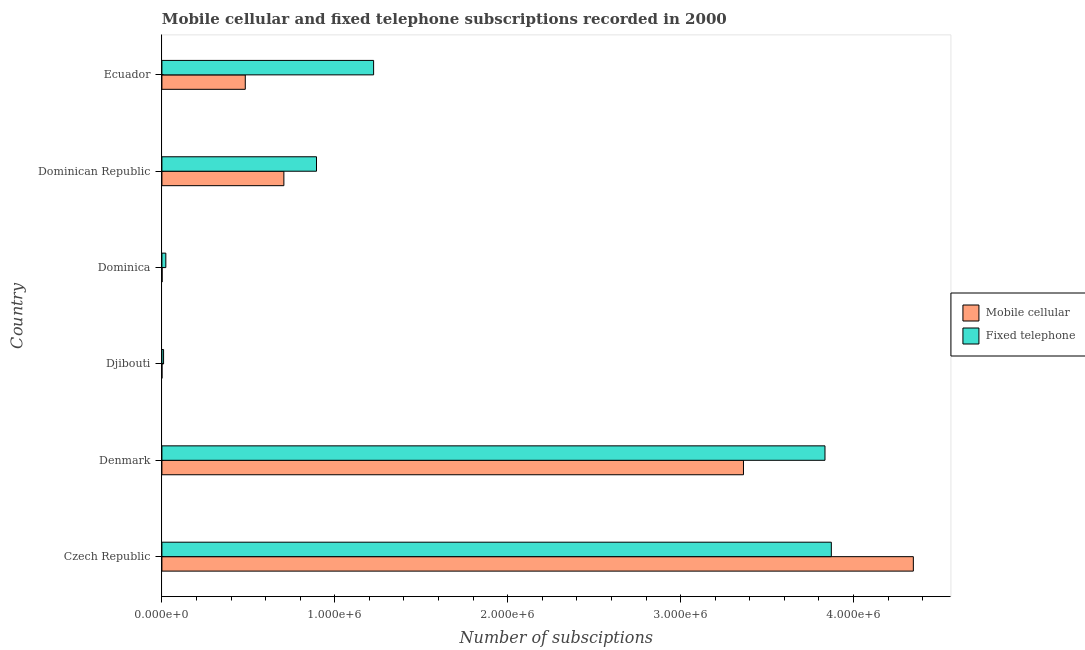Are the number of bars per tick equal to the number of legend labels?
Provide a succinct answer. Yes. Are the number of bars on each tick of the Y-axis equal?
Provide a succinct answer. Yes. What is the label of the 3rd group of bars from the top?
Ensure brevity in your answer.  Dominica. In how many cases, is the number of bars for a given country not equal to the number of legend labels?
Your answer should be very brief. 0. What is the number of fixed telephone subscriptions in Czech Republic?
Provide a succinct answer. 3.87e+06. Across all countries, what is the maximum number of fixed telephone subscriptions?
Ensure brevity in your answer.  3.87e+06. Across all countries, what is the minimum number of fixed telephone subscriptions?
Provide a short and direct response. 9704. In which country was the number of mobile cellular subscriptions maximum?
Offer a very short reply. Czech Republic. In which country was the number of mobile cellular subscriptions minimum?
Your answer should be compact. Djibouti. What is the total number of mobile cellular subscriptions in the graph?
Keep it short and to the point. 8.90e+06. What is the difference between the number of fixed telephone subscriptions in Denmark and that in Dominican Republic?
Offer a very short reply. 2.94e+06. What is the difference between the number of mobile cellular subscriptions in Dominican Republic and the number of fixed telephone subscriptions in Dominica?
Provide a short and direct response. 6.83e+05. What is the average number of fixed telephone subscriptions per country?
Your answer should be very brief. 1.64e+06. What is the difference between the number of fixed telephone subscriptions and number of mobile cellular subscriptions in Djibouti?
Offer a terse response. 9474. In how many countries, is the number of fixed telephone subscriptions greater than 2600000 ?
Ensure brevity in your answer.  2. What is the ratio of the number of mobile cellular subscriptions in Dominica to that in Ecuador?
Your response must be concise. 0. What is the difference between the highest and the second highest number of mobile cellular subscriptions?
Keep it short and to the point. 9.82e+05. What is the difference between the highest and the lowest number of fixed telephone subscriptions?
Provide a succinct answer. 3.86e+06. Is the sum of the number of mobile cellular subscriptions in Czech Republic and Dominica greater than the maximum number of fixed telephone subscriptions across all countries?
Offer a very short reply. Yes. What does the 1st bar from the top in Denmark represents?
Ensure brevity in your answer.  Fixed telephone. What does the 1st bar from the bottom in Denmark represents?
Offer a terse response. Mobile cellular. Are all the bars in the graph horizontal?
Ensure brevity in your answer.  Yes. How many countries are there in the graph?
Keep it short and to the point. 6. Are the values on the major ticks of X-axis written in scientific E-notation?
Offer a terse response. Yes. Does the graph contain any zero values?
Keep it short and to the point. No. Where does the legend appear in the graph?
Ensure brevity in your answer.  Center right. How many legend labels are there?
Provide a succinct answer. 2. What is the title of the graph?
Your response must be concise. Mobile cellular and fixed telephone subscriptions recorded in 2000. Does "Overweight" appear as one of the legend labels in the graph?
Make the answer very short. No. What is the label or title of the X-axis?
Offer a terse response. Number of subsciptions. What is the label or title of the Y-axis?
Give a very brief answer. Country. What is the Number of subsciptions in Mobile cellular in Czech Republic?
Keep it short and to the point. 4.35e+06. What is the Number of subsciptions of Fixed telephone in Czech Republic?
Offer a terse response. 3.87e+06. What is the Number of subsciptions of Mobile cellular in Denmark?
Your answer should be compact. 3.36e+06. What is the Number of subsciptions in Fixed telephone in Denmark?
Keep it short and to the point. 3.84e+06. What is the Number of subsciptions of Mobile cellular in Djibouti?
Provide a short and direct response. 230. What is the Number of subsciptions in Fixed telephone in Djibouti?
Ensure brevity in your answer.  9704. What is the Number of subsciptions of Mobile cellular in Dominica?
Make the answer very short. 1200. What is the Number of subsciptions in Fixed telephone in Dominica?
Give a very brief answer. 2.27e+04. What is the Number of subsciptions in Mobile cellular in Dominican Republic?
Offer a very short reply. 7.05e+05. What is the Number of subsciptions of Fixed telephone in Dominican Republic?
Keep it short and to the point. 8.94e+05. What is the Number of subsciptions in Mobile cellular in Ecuador?
Make the answer very short. 4.82e+05. What is the Number of subsciptions in Fixed telephone in Ecuador?
Provide a short and direct response. 1.22e+06. Across all countries, what is the maximum Number of subsciptions of Mobile cellular?
Provide a succinct answer. 4.35e+06. Across all countries, what is the maximum Number of subsciptions of Fixed telephone?
Offer a very short reply. 3.87e+06. Across all countries, what is the minimum Number of subsciptions in Mobile cellular?
Your answer should be very brief. 230. Across all countries, what is the minimum Number of subsciptions in Fixed telephone?
Your answer should be compact. 9704. What is the total Number of subsciptions in Mobile cellular in the graph?
Ensure brevity in your answer.  8.90e+06. What is the total Number of subsciptions in Fixed telephone in the graph?
Your response must be concise. 9.86e+06. What is the difference between the Number of subsciptions in Mobile cellular in Czech Republic and that in Denmark?
Keep it short and to the point. 9.82e+05. What is the difference between the Number of subsciptions in Fixed telephone in Czech Republic and that in Denmark?
Provide a short and direct response. 3.67e+04. What is the difference between the Number of subsciptions of Mobile cellular in Czech Republic and that in Djibouti?
Offer a very short reply. 4.35e+06. What is the difference between the Number of subsciptions in Fixed telephone in Czech Republic and that in Djibouti?
Give a very brief answer. 3.86e+06. What is the difference between the Number of subsciptions in Mobile cellular in Czech Republic and that in Dominica?
Your answer should be very brief. 4.34e+06. What is the difference between the Number of subsciptions of Fixed telephone in Czech Republic and that in Dominica?
Offer a terse response. 3.85e+06. What is the difference between the Number of subsciptions of Mobile cellular in Czech Republic and that in Dominican Republic?
Make the answer very short. 3.64e+06. What is the difference between the Number of subsciptions in Fixed telephone in Czech Republic and that in Dominican Republic?
Make the answer very short. 2.98e+06. What is the difference between the Number of subsciptions of Mobile cellular in Czech Republic and that in Ecuador?
Offer a very short reply. 3.86e+06. What is the difference between the Number of subsciptions in Fixed telephone in Czech Republic and that in Ecuador?
Provide a succinct answer. 2.65e+06. What is the difference between the Number of subsciptions of Mobile cellular in Denmark and that in Djibouti?
Give a very brief answer. 3.36e+06. What is the difference between the Number of subsciptions in Fixed telephone in Denmark and that in Djibouti?
Offer a very short reply. 3.83e+06. What is the difference between the Number of subsciptions in Mobile cellular in Denmark and that in Dominica?
Keep it short and to the point. 3.36e+06. What is the difference between the Number of subsciptions of Fixed telephone in Denmark and that in Dominica?
Give a very brief answer. 3.81e+06. What is the difference between the Number of subsciptions in Mobile cellular in Denmark and that in Dominican Republic?
Your answer should be very brief. 2.66e+06. What is the difference between the Number of subsciptions of Fixed telephone in Denmark and that in Dominican Republic?
Offer a terse response. 2.94e+06. What is the difference between the Number of subsciptions of Mobile cellular in Denmark and that in Ecuador?
Offer a terse response. 2.88e+06. What is the difference between the Number of subsciptions in Fixed telephone in Denmark and that in Ecuador?
Provide a succinct answer. 2.61e+06. What is the difference between the Number of subsciptions in Mobile cellular in Djibouti and that in Dominica?
Make the answer very short. -970. What is the difference between the Number of subsciptions in Fixed telephone in Djibouti and that in Dominica?
Your answer should be compact. -1.30e+04. What is the difference between the Number of subsciptions in Mobile cellular in Djibouti and that in Dominican Republic?
Make the answer very short. -7.05e+05. What is the difference between the Number of subsciptions in Fixed telephone in Djibouti and that in Dominican Republic?
Offer a terse response. -8.84e+05. What is the difference between the Number of subsciptions of Mobile cellular in Djibouti and that in Ecuador?
Make the answer very short. -4.82e+05. What is the difference between the Number of subsciptions in Fixed telephone in Djibouti and that in Ecuador?
Offer a terse response. -1.21e+06. What is the difference between the Number of subsciptions in Mobile cellular in Dominica and that in Dominican Republic?
Offer a terse response. -7.04e+05. What is the difference between the Number of subsciptions of Fixed telephone in Dominica and that in Dominican Republic?
Provide a succinct answer. -8.71e+05. What is the difference between the Number of subsciptions in Mobile cellular in Dominica and that in Ecuador?
Provide a succinct answer. -4.81e+05. What is the difference between the Number of subsciptions in Fixed telephone in Dominica and that in Ecuador?
Provide a succinct answer. -1.20e+06. What is the difference between the Number of subsciptions in Mobile cellular in Dominican Republic and that in Ecuador?
Ensure brevity in your answer.  2.23e+05. What is the difference between the Number of subsciptions of Fixed telephone in Dominican Republic and that in Ecuador?
Offer a very short reply. -3.30e+05. What is the difference between the Number of subsciptions of Mobile cellular in Czech Republic and the Number of subsciptions of Fixed telephone in Denmark?
Your response must be concise. 5.11e+05. What is the difference between the Number of subsciptions in Mobile cellular in Czech Republic and the Number of subsciptions in Fixed telephone in Djibouti?
Ensure brevity in your answer.  4.34e+06. What is the difference between the Number of subsciptions of Mobile cellular in Czech Republic and the Number of subsciptions of Fixed telephone in Dominica?
Your response must be concise. 4.32e+06. What is the difference between the Number of subsciptions in Mobile cellular in Czech Republic and the Number of subsciptions in Fixed telephone in Dominican Republic?
Offer a terse response. 3.45e+06. What is the difference between the Number of subsciptions in Mobile cellular in Czech Republic and the Number of subsciptions in Fixed telephone in Ecuador?
Your response must be concise. 3.12e+06. What is the difference between the Number of subsciptions of Mobile cellular in Denmark and the Number of subsciptions of Fixed telephone in Djibouti?
Ensure brevity in your answer.  3.35e+06. What is the difference between the Number of subsciptions of Mobile cellular in Denmark and the Number of subsciptions of Fixed telephone in Dominica?
Your response must be concise. 3.34e+06. What is the difference between the Number of subsciptions of Mobile cellular in Denmark and the Number of subsciptions of Fixed telephone in Dominican Republic?
Keep it short and to the point. 2.47e+06. What is the difference between the Number of subsciptions in Mobile cellular in Denmark and the Number of subsciptions in Fixed telephone in Ecuador?
Offer a terse response. 2.14e+06. What is the difference between the Number of subsciptions of Mobile cellular in Djibouti and the Number of subsciptions of Fixed telephone in Dominica?
Your answer should be very brief. -2.25e+04. What is the difference between the Number of subsciptions in Mobile cellular in Djibouti and the Number of subsciptions in Fixed telephone in Dominican Republic?
Give a very brief answer. -8.94e+05. What is the difference between the Number of subsciptions in Mobile cellular in Djibouti and the Number of subsciptions in Fixed telephone in Ecuador?
Ensure brevity in your answer.  -1.22e+06. What is the difference between the Number of subsciptions in Mobile cellular in Dominica and the Number of subsciptions in Fixed telephone in Dominican Republic?
Your answer should be compact. -8.93e+05. What is the difference between the Number of subsciptions in Mobile cellular in Dominica and the Number of subsciptions in Fixed telephone in Ecuador?
Offer a very short reply. -1.22e+06. What is the difference between the Number of subsciptions in Mobile cellular in Dominican Republic and the Number of subsciptions in Fixed telephone in Ecuador?
Give a very brief answer. -5.19e+05. What is the average Number of subsciptions of Mobile cellular per country?
Your answer should be compact. 1.48e+06. What is the average Number of subsciptions in Fixed telephone per country?
Provide a succinct answer. 1.64e+06. What is the difference between the Number of subsciptions in Mobile cellular and Number of subsciptions in Fixed telephone in Czech Republic?
Make the answer very short. 4.74e+05. What is the difference between the Number of subsciptions of Mobile cellular and Number of subsciptions of Fixed telephone in Denmark?
Keep it short and to the point. -4.71e+05. What is the difference between the Number of subsciptions in Mobile cellular and Number of subsciptions in Fixed telephone in Djibouti?
Ensure brevity in your answer.  -9474. What is the difference between the Number of subsciptions in Mobile cellular and Number of subsciptions in Fixed telephone in Dominica?
Keep it short and to the point. -2.15e+04. What is the difference between the Number of subsciptions in Mobile cellular and Number of subsciptions in Fixed telephone in Dominican Republic?
Keep it short and to the point. -1.89e+05. What is the difference between the Number of subsciptions of Mobile cellular and Number of subsciptions of Fixed telephone in Ecuador?
Your answer should be compact. -7.42e+05. What is the ratio of the Number of subsciptions of Mobile cellular in Czech Republic to that in Denmark?
Offer a very short reply. 1.29. What is the ratio of the Number of subsciptions in Fixed telephone in Czech Republic to that in Denmark?
Your response must be concise. 1.01. What is the ratio of the Number of subsciptions in Mobile cellular in Czech Republic to that in Djibouti?
Your answer should be very brief. 1.89e+04. What is the ratio of the Number of subsciptions of Fixed telephone in Czech Republic to that in Djibouti?
Your answer should be very brief. 398.97. What is the ratio of the Number of subsciptions in Mobile cellular in Czech Republic to that in Dominica?
Offer a very short reply. 3621.67. What is the ratio of the Number of subsciptions of Fixed telephone in Czech Republic to that in Dominica?
Your answer should be very brief. 170.56. What is the ratio of the Number of subsciptions in Mobile cellular in Czech Republic to that in Dominican Republic?
Provide a short and direct response. 6.16. What is the ratio of the Number of subsciptions in Fixed telephone in Czech Republic to that in Dominican Republic?
Ensure brevity in your answer.  4.33. What is the ratio of the Number of subsciptions of Mobile cellular in Czech Republic to that in Ecuador?
Keep it short and to the point. 9.01. What is the ratio of the Number of subsciptions in Fixed telephone in Czech Republic to that in Ecuador?
Provide a short and direct response. 3.16. What is the ratio of the Number of subsciptions in Mobile cellular in Denmark to that in Djibouti?
Your answer should be compact. 1.46e+04. What is the ratio of the Number of subsciptions of Fixed telephone in Denmark to that in Djibouti?
Keep it short and to the point. 395.2. What is the ratio of the Number of subsciptions of Mobile cellular in Denmark to that in Dominica?
Offer a terse response. 2802.96. What is the ratio of the Number of subsciptions of Fixed telephone in Denmark to that in Dominica?
Provide a succinct answer. 168.94. What is the ratio of the Number of subsciptions in Mobile cellular in Denmark to that in Dominican Republic?
Ensure brevity in your answer.  4.77. What is the ratio of the Number of subsciptions in Fixed telephone in Denmark to that in Dominican Republic?
Give a very brief answer. 4.29. What is the ratio of the Number of subsciptions of Mobile cellular in Denmark to that in Ecuador?
Provide a succinct answer. 6.98. What is the ratio of the Number of subsciptions in Fixed telephone in Denmark to that in Ecuador?
Make the answer very short. 3.13. What is the ratio of the Number of subsciptions of Mobile cellular in Djibouti to that in Dominica?
Your response must be concise. 0.19. What is the ratio of the Number of subsciptions of Fixed telephone in Djibouti to that in Dominica?
Ensure brevity in your answer.  0.43. What is the ratio of the Number of subsciptions of Mobile cellular in Djibouti to that in Dominican Republic?
Your answer should be very brief. 0. What is the ratio of the Number of subsciptions of Fixed telephone in Djibouti to that in Dominican Republic?
Give a very brief answer. 0.01. What is the ratio of the Number of subsciptions of Fixed telephone in Djibouti to that in Ecuador?
Make the answer very short. 0.01. What is the ratio of the Number of subsciptions of Mobile cellular in Dominica to that in Dominican Republic?
Provide a short and direct response. 0. What is the ratio of the Number of subsciptions in Fixed telephone in Dominica to that in Dominican Republic?
Make the answer very short. 0.03. What is the ratio of the Number of subsciptions in Mobile cellular in Dominica to that in Ecuador?
Make the answer very short. 0. What is the ratio of the Number of subsciptions in Fixed telephone in Dominica to that in Ecuador?
Provide a succinct answer. 0.02. What is the ratio of the Number of subsciptions in Mobile cellular in Dominican Republic to that in Ecuador?
Your answer should be very brief. 1.46. What is the ratio of the Number of subsciptions in Fixed telephone in Dominican Republic to that in Ecuador?
Make the answer very short. 0.73. What is the difference between the highest and the second highest Number of subsciptions of Mobile cellular?
Your answer should be very brief. 9.82e+05. What is the difference between the highest and the second highest Number of subsciptions of Fixed telephone?
Offer a terse response. 3.67e+04. What is the difference between the highest and the lowest Number of subsciptions of Mobile cellular?
Offer a very short reply. 4.35e+06. What is the difference between the highest and the lowest Number of subsciptions of Fixed telephone?
Provide a succinct answer. 3.86e+06. 